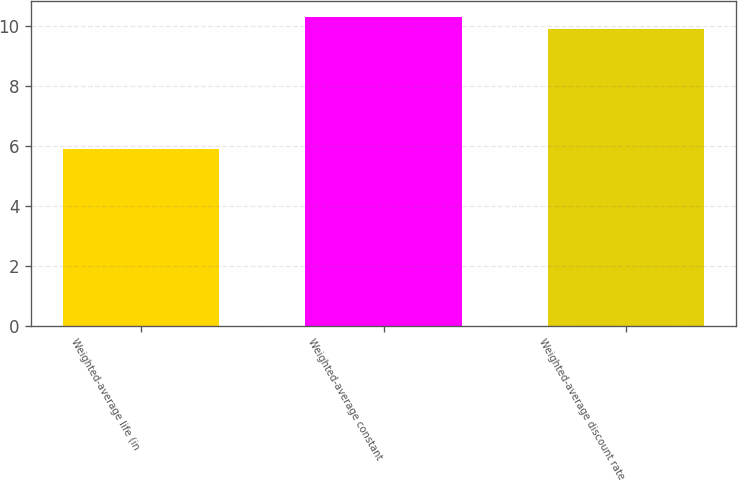Convert chart. <chart><loc_0><loc_0><loc_500><loc_500><bar_chart><fcel>Weighted-average life (in<fcel>Weighted-average constant<fcel>Weighted-average discount rate<nl><fcel>5.9<fcel>10.31<fcel>9.9<nl></chart> 